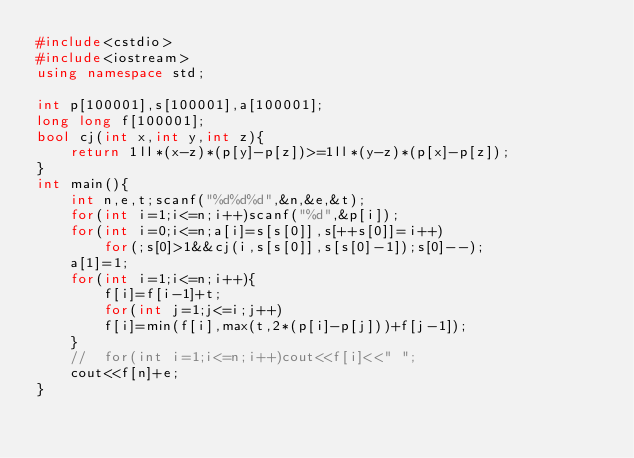<code> <loc_0><loc_0><loc_500><loc_500><_C++_>#include<cstdio>
#include<iostream>
using namespace std;

int p[100001],s[100001],a[100001];
long long f[100001];
bool cj(int x,int y,int z){
	return 1ll*(x-z)*(p[y]-p[z])>=1ll*(y-z)*(p[x]-p[z]);
}
int main(){
	int n,e,t;scanf("%d%d%d",&n,&e,&t);
	for(int i=1;i<=n;i++)scanf("%d",&p[i]);
	for(int i=0;i<=n;a[i]=s[s[0]],s[++s[0]]=i++)
		for(;s[0]>1&&cj(i,s[s[0]],s[s[0]-1]);s[0]--);
	a[1]=1;
	for(int i=1;i<=n;i++){
		f[i]=f[i-1]+t;
		for(int j=1;j<=i;j++)
		f[i]=min(f[i],max(t,2*(p[i]-p[j]))+f[j-1]);
	}
	//	for(int i=1;i<=n;i++)cout<<f[i]<<" ";
	cout<<f[n]+e;
}</code> 